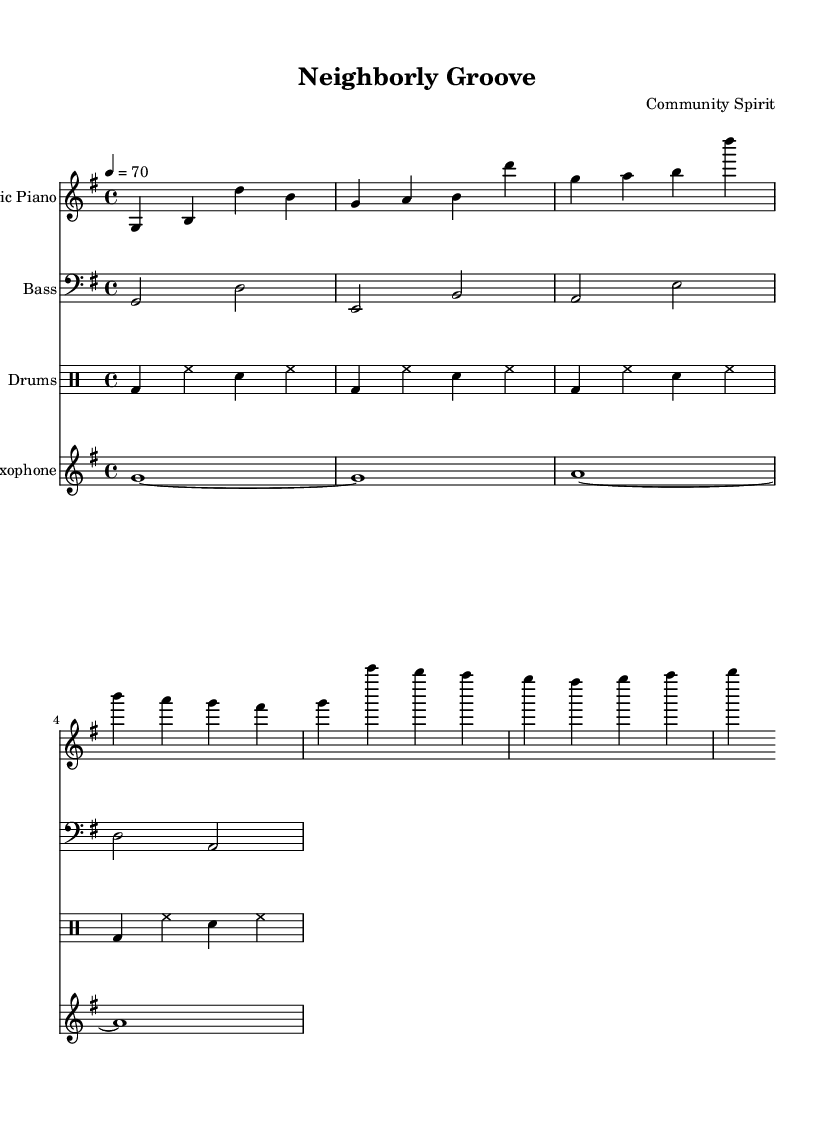What is the key signature of this music? The key signature is G major, which has one sharp (F#).
Answer: G major What is the time signature of this music? The time signature is indicated at the beginning of the score as 4/4, meaning there are four beats in a measure.
Answer: 4/4 What is the tempo marking for this piece? The tempo marking is 70 beats per minute, specified by the "4 = 70" indication.
Answer: 70 How many instruments are specified in this score? The score indicates four distinct instruments: Electric Piano, Bass, Drums, and Saxophone.
Answer: Four What is the main rhythmic pattern used in the drums part? The main rhythmic pattern consists mainly of bass drum beats on the first and third beats, and hi-hat and snare hits throughout.
Answer: Bass, hi-hat, snare What type of instrumental texture is prevalent in this piece? The texture is primarily homophonic, with one main melodic line accompanied by harmonic support from the bass and piano.
Answer: Homophonic What is the primary role of the saxophone in this composition? The saxophone primarily plays sustained notes, providing a melodic element that enhances the smoothness of the piece.
Answer: Melodic element 